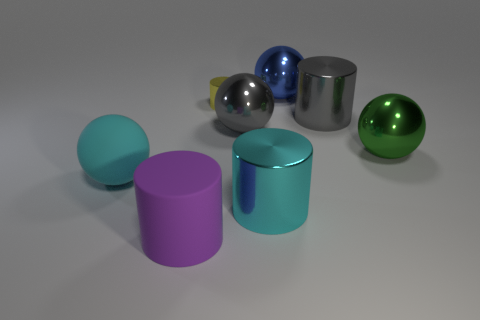There is a big thing that is the same color as the large matte sphere; what is it made of?
Your answer should be compact. Metal. Do the matte sphere and the large metal cylinder to the left of the large blue thing have the same color?
Keep it short and to the point. Yes. There is a small yellow object that is the same material as the blue ball; what is its shape?
Offer a very short reply. Cylinder. What number of tiny metallic things are the same shape as the purple rubber thing?
Provide a succinct answer. 1. There is a large gray object on the right side of the metal cylinder in front of the cyan ball; what shape is it?
Provide a succinct answer. Cylinder. There is a gray shiny object that is left of the blue object; is its size the same as the tiny shiny cylinder?
Give a very brief answer. No. There is a metallic cylinder that is both left of the big blue thing and behind the cyan cylinder; how big is it?
Your response must be concise. Small. What number of purple things have the same size as the cyan rubber object?
Offer a very short reply. 1. How many big rubber cylinders are to the right of the cylinder that is on the left side of the yellow metallic thing?
Offer a terse response. 0. Is the color of the metal cylinder that is in front of the large gray sphere the same as the matte sphere?
Ensure brevity in your answer.  Yes. 